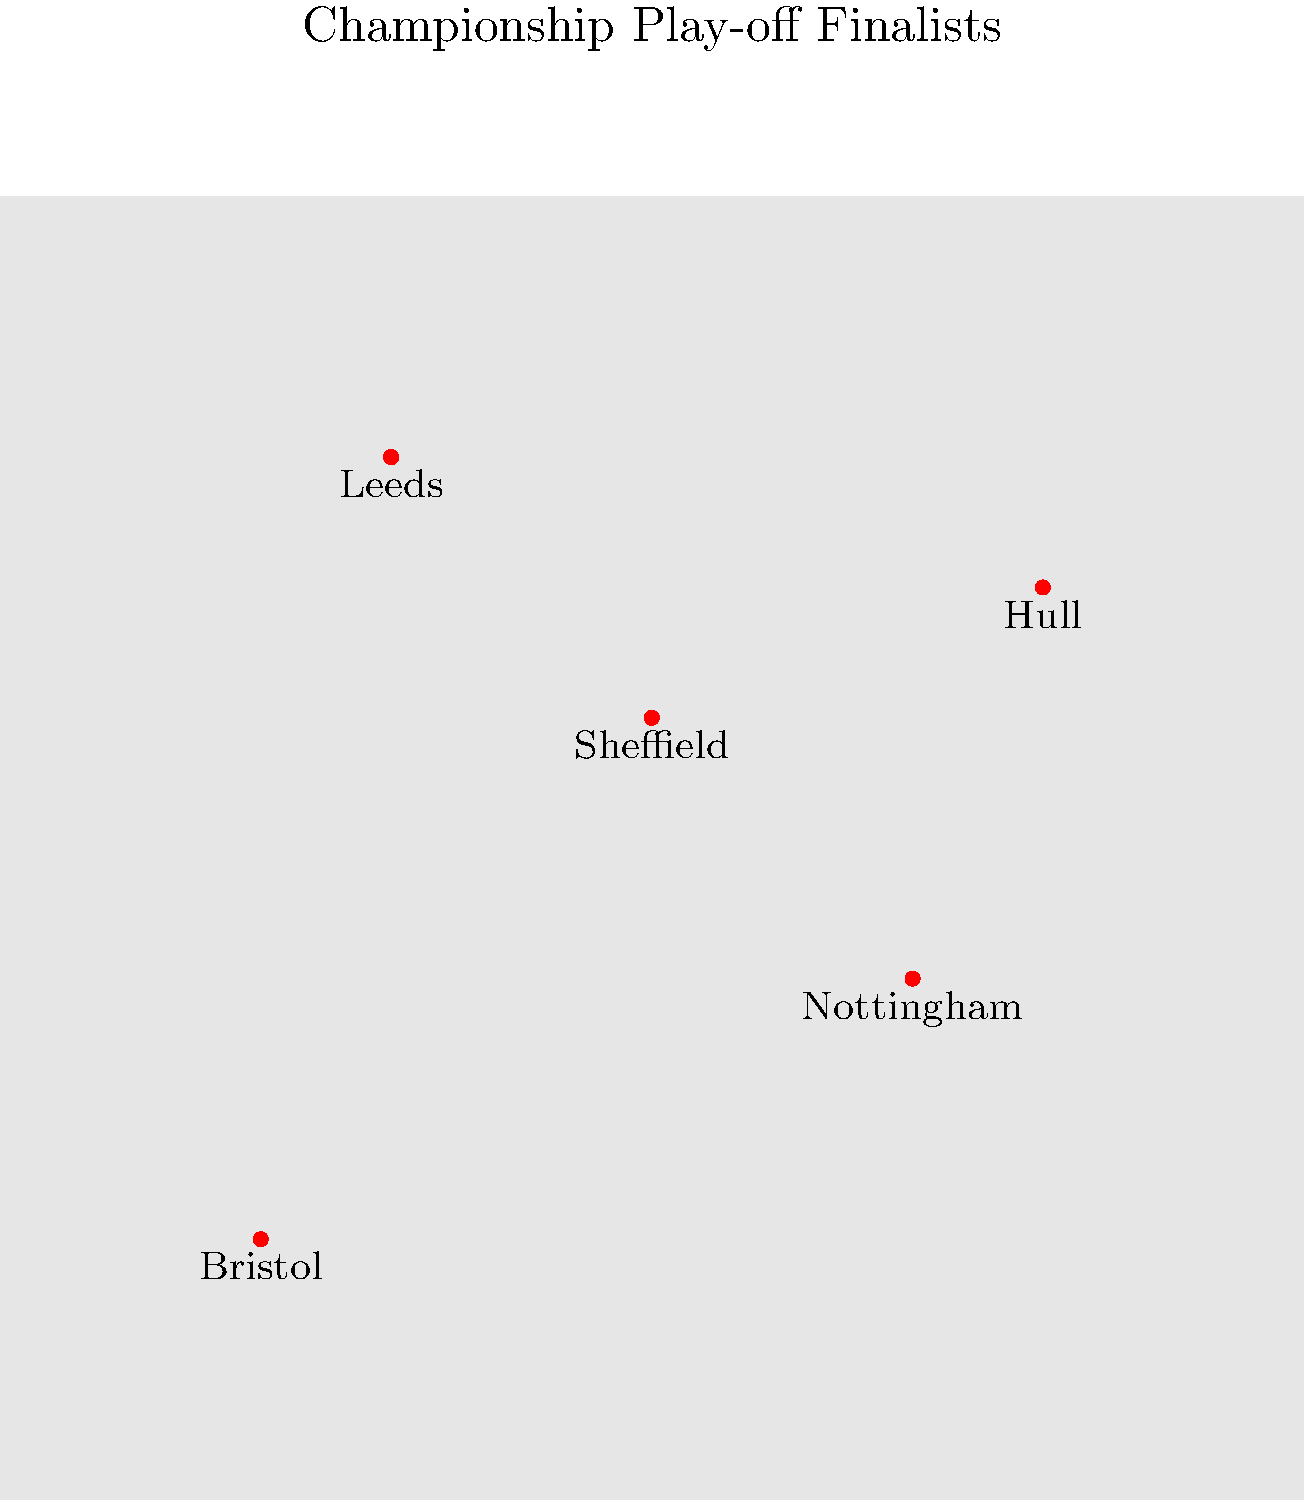Based on the map showing the geographical distribution of Championship play-off finalists, which team is located the furthest north? To determine the team located furthest north, we need to follow these steps:

1. Understand that in maps of England, north is typically at the top of the map.
2. Identify all teams marked on the map: Leeds, Sheffield, Nottingham, Bristol, and Hull.
3. Compare the vertical positions of these cities on the map:
   - Leeds is positioned highest on the map.
   - Hull is slightly below Leeds.
   - Sheffield is below Hull.
   - Nottingham is further south.
   - Bristol is the southernmost city marked.
4. Conclude that the highest point on the map corresponds to the northernmost location.

Therefore, Leeds, being at the highest point on the map, is the team located furthest north among the Championship play-off finalists shown.
Answer: Leeds 